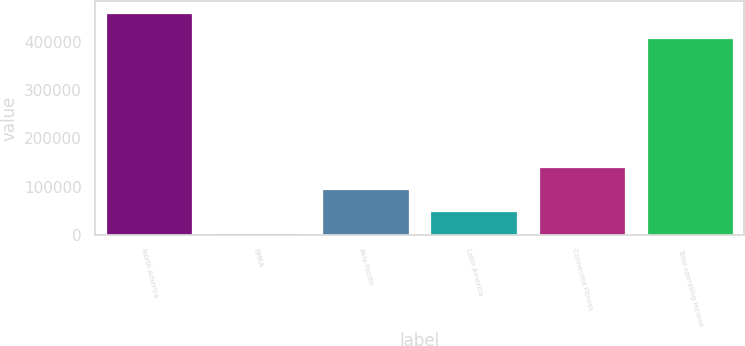<chart> <loc_0><loc_0><loc_500><loc_500><bar_chart><fcel>North America<fcel>EMEA<fcel>Asia-Pacific<fcel>Latin America<fcel>Connected Fitness<fcel>Total operating income<nl><fcel>460961<fcel>3122<fcel>94689.8<fcel>48905.9<fcel>140474<fcel>408547<nl></chart> 